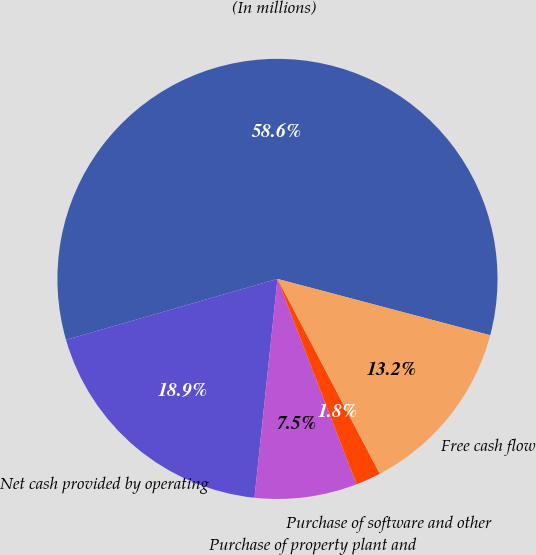Convert chart to OTSL. <chart><loc_0><loc_0><loc_500><loc_500><pie_chart><fcel>(In millions)<fcel>Net cash provided by operating<fcel>Purchase of property plant and<fcel>Purchase of software and other<fcel>Free cash flow<nl><fcel>58.59%<fcel>18.87%<fcel>7.52%<fcel>1.84%<fcel>13.19%<nl></chart> 